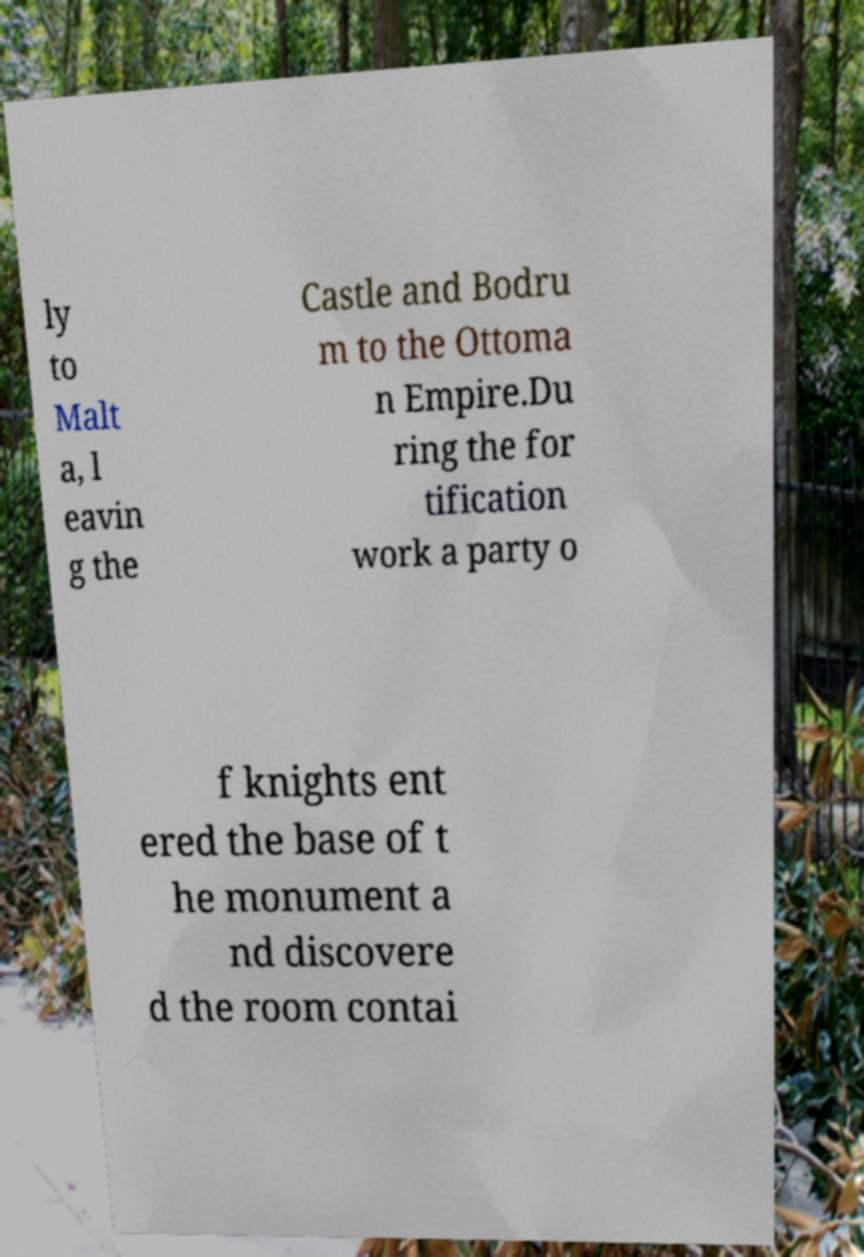Please identify and transcribe the text found in this image. ly to Malt a, l eavin g the Castle and Bodru m to the Ottoma n Empire.Du ring the for tification work a party o f knights ent ered the base of t he monument a nd discovere d the room contai 